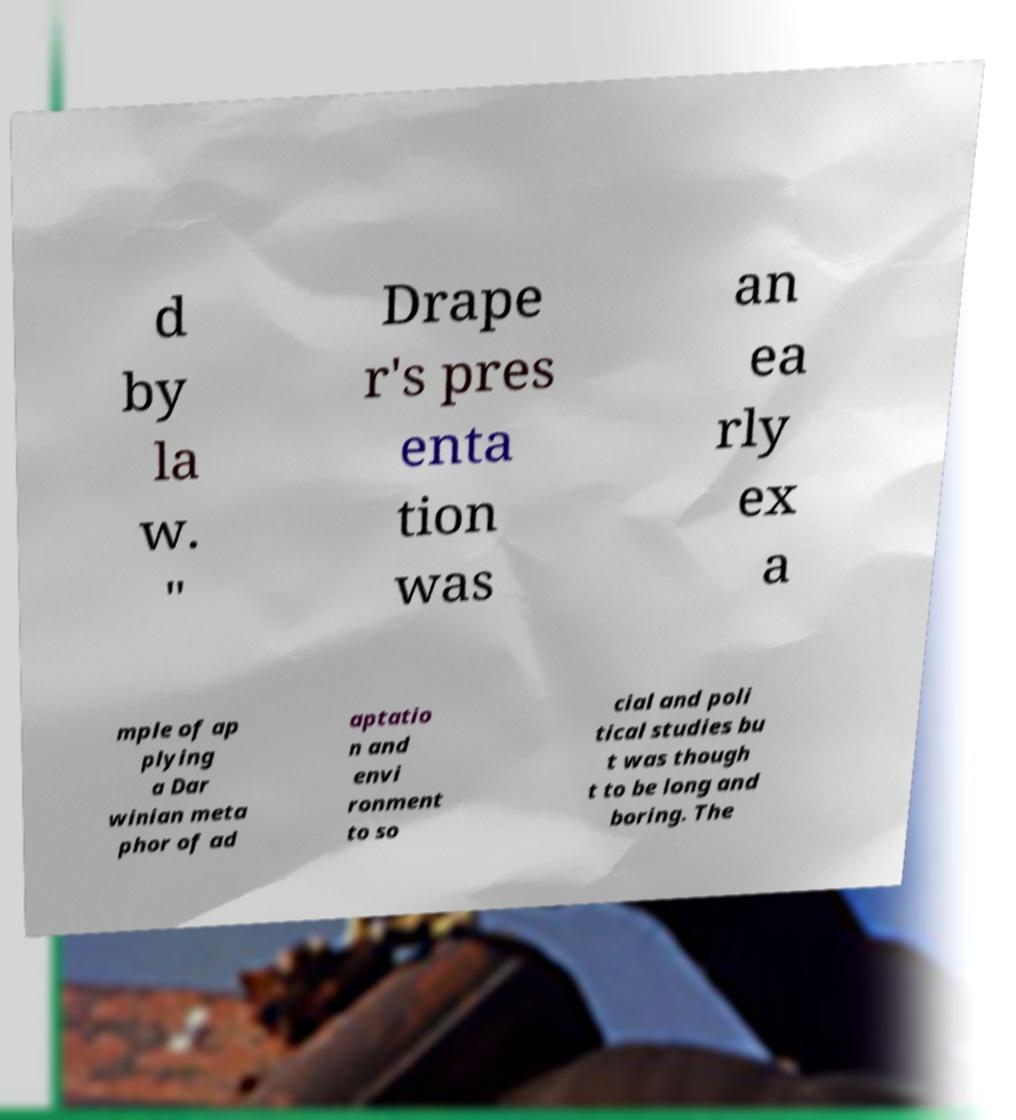Can you read and provide the text displayed in the image?This photo seems to have some interesting text. Can you extract and type it out for me? d by la w. " Drape r's pres enta tion was an ea rly ex a mple of ap plying a Dar winian meta phor of ad aptatio n and envi ronment to so cial and poli tical studies bu t was though t to be long and boring. The 